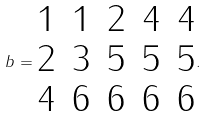<formula> <loc_0><loc_0><loc_500><loc_500>b = \begin{matrix} 1 & 1 & 2 & 4 & 4 \\ 2 & 3 & 5 & 5 & 5 \\ 4 & 6 & 6 & 6 & 6 \end{matrix} .</formula> 